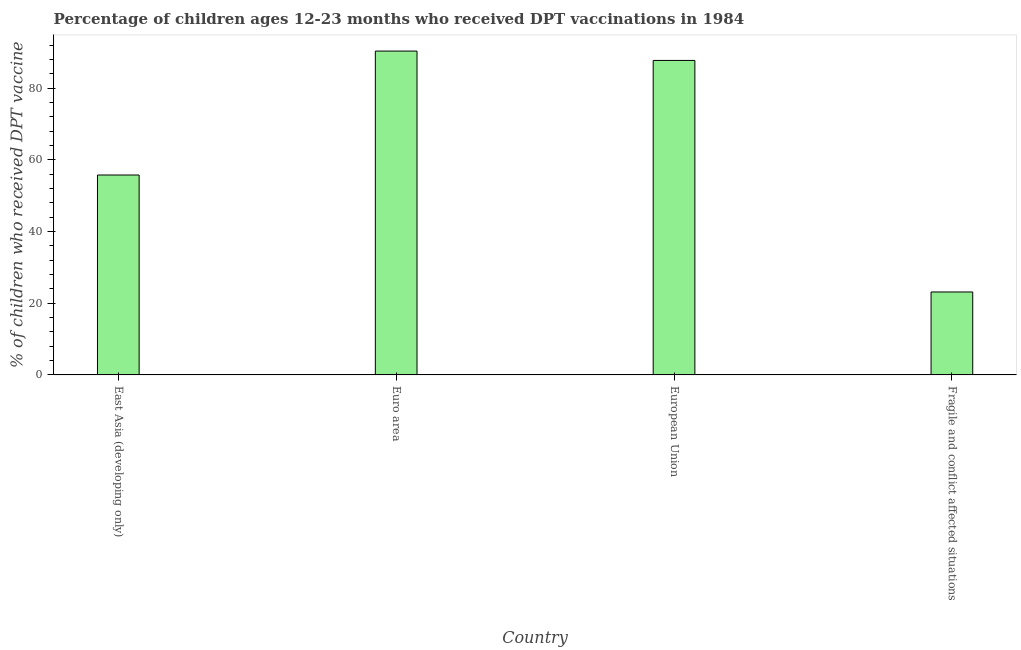What is the title of the graph?
Your answer should be compact. Percentage of children ages 12-23 months who received DPT vaccinations in 1984. What is the label or title of the Y-axis?
Keep it short and to the point. % of children who received DPT vaccine. What is the percentage of children who received dpt vaccine in European Union?
Your answer should be compact. 87.71. Across all countries, what is the maximum percentage of children who received dpt vaccine?
Make the answer very short. 90.33. Across all countries, what is the minimum percentage of children who received dpt vaccine?
Ensure brevity in your answer.  23.13. In which country was the percentage of children who received dpt vaccine minimum?
Offer a very short reply. Fragile and conflict affected situations. What is the sum of the percentage of children who received dpt vaccine?
Your answer should be compact. 256.93. What is the difference between the percentage of children who received dpt vaccine in East Asia (developing only) and Fragile and conflict affected situations?
Give a very brief answer. 32.63. What is the average percentage of children who received dpt vaccine per country?
Offer a terse response. 64.23. What is the median percentage of children who received dpt vaccine?
Your answer should be compact. 71.74. What is the ratio of the percentage of children who received dpt vaccine in East Asia (developing only) to that in Euro area?
Your answer should be very brief. 0.62. Is the percentage of children who received dpt vaccine in Euro area less than that in European Union?
Offer a terse response. No. Is the difference between the percentage of children who received dpt vaccine in Euro area and European Union greater than the difference between any two countries?
Offer a terse response. No. What is the difference between the highest and the second highest percentage of children who received dpt vaccine?
Make the answer very short. 2.61. Is the sum of the percentage of children who received dpt vaccine in East Asia (developing only) and Fragile and conflict affected situations greater than the maximum percentage of children who received dpt vaccine across all countries?
Ensure brevity in your answer.  No. What is the difference between the highest and the lowest percentage of children who received dpt vaccine?
Your answer should be compact. 67.2. How many bars are there?
Provide a short and direct response. 4. Are all the bars in the graph horizontal?
Keep it short and to the point. No. How many countries are there in the graph?
Make the answer very short. 4. What is the difference between two consecutive major ticks on the Y-axis?
Offer a terse response. 20. What is the % of children who received DPT vaccine in East Asia (developing only)?
Make the answer very short. 55.76. What is the % of children who received DPT vaccine of Euro area?
Your response must be concise. 90.33. What is the % of children who received DPT vaccine of European Union?
Offer a terse response. 87.71. What is the % of children who received DPT vaccine in Fragile and conflict affected situations?
Your answer should be compact. 23.13. What is the difference between the % of children who received DPT vaccine in East Asia (developing only) and Euro area?
Provide a succinct answer. -34.57. What is the difference between the % of children who received DPT vaccine in East Asia (developing only) and European Union?
Offer a terse response. -31.96. What is the difference between the % of children who received DPT vaccine in East Asia (developing only) and Fragile and conflict affected situations?
Provide a succinct answer. 32.63. What is the difference between the % of children who received DPT vaccine in Euro area and European Union?
Your answer should be very brief. 2.61. What is the difference between the % of children who received DPT vaccine in Euro area and Fragile and conflict affected situations?
Ensure brevity in your answer.  67.2. What is the difference between the % of children who received DPT vaccine in European Union and Fragile and conflict affected situations?
Provide a succinct answer. 64.58. What is the ratio of the % of children who received DPT vaccine in East Asia (developing only) to that in Euro area?
Offer a terse response. 0.62. What is the ratio of the % of children who received DPT vaccine in East Asia (developing only) to that in European Union?
Ensure brevity in your answer.  0.64. What is the ratio of the % of children who received DPT vaccine in East Asia (developing only) to that in Fragile and conflict affected situations?
Offer a terse response. 2.41. What is the ratio of the % of children who received DPT vaccine in Euro area to that in Fragile and conflict affected situations?
Offer a very short reply. 3.9. What is the ratio of the % of children who received DPT vaccine in European Union to that in Fragile and conflict affected situations?
Make the answer very short. 3.79. 